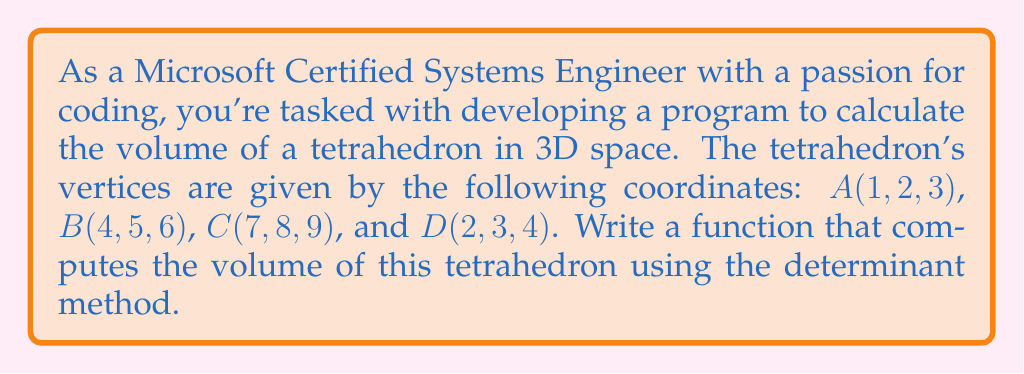Help me with this question. To solve this problem, we'll follow these steps:

1) The volume of a tetrahedron can be calculated using the formula:

   $$V = \frac{1}{6}|\det(\vec{AB}, \vec{AC}, \vec{AD})|$$

   where $\vec{AB}$, $\vec{AC}$, and $\vec{AD}$ are vectors from point A to B, C, and D respectively.

2) First, let's calculate these vectors:

   $\vec{AB} = B - A = (4-1, 5-2, 6-3) = (3, 3, 3)$
   $\vec{AC} = C - A = (7-1, 8-2, 9-3) = (6, 6, 6)$
   $\vec{AD} = D - A = (2-1, 3-2, 4-3) = (1, 1, 1)$

3) Now, we need to calculate the determinant of the matrix formed by these vectors:

   $$\det = \begin{vmatrix}
   3 & 6 & 1 \\
   3 & 6 & 1 \\
   3 & 6 & 1
   \end{vmatrix}$$

4) To calculate this determinant, we can use the Sarrus' rule or expand along a row or column. Let's expand along the first row:

   $\det = 3(6 \cdot 1 - 1 \cdot 6) - 6(3 \cdot 1 - 1 \cdot 3) + 1(3 \cdot 6 - 6 \cdot 3) = 3(0) - 6(0) + 1(0) = 0$

5) The volume is then:

   $$V = \frac{1}{6}|0| = 0$$

This means the tetrahedron is degenerate (flat) and has no volume.
Answer: 0 cubic units 